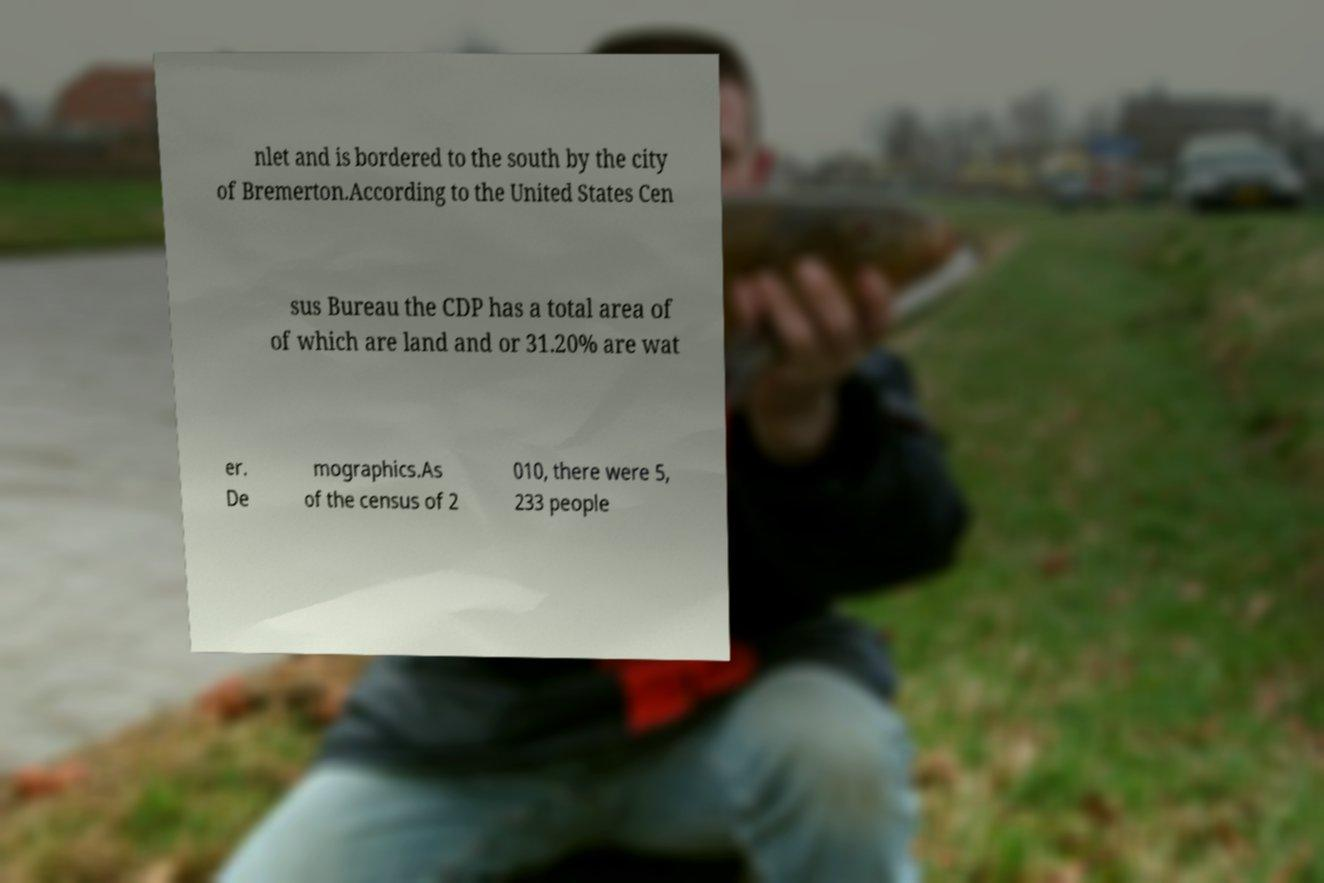What messages or text are displayed in this image? I need them in a readable, typed format. nlet and is bordered to the south by the city of Bremerton.According to the United States Cen sus Bureau the CDP has a total area of of which are land and or 31.20% are wat er. De mographics.As of the census of 2 010, there were 5, 233 people 